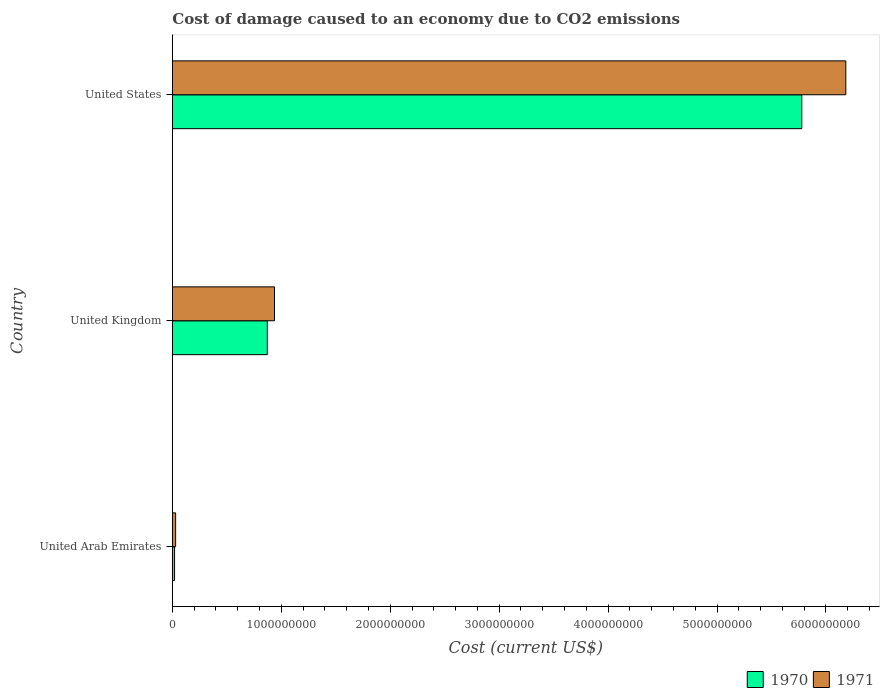How many different coloured bars are there?
Make the answer very short. 2. Are the number of bars per tick equal to the number of legend labels?
Provide a succinct answer. Yes. How many bars are there on the 2nd tick from the bottom?
Your answer should be very brief. 2. What is the label of the 3rd group of bars from the top?
Give a very brief answer. United Arab Emirates. What is the cost of damage caused due to CO2 emissisons in 1971 in United Arab Emirates?
Your answer should be very brief. 3.01e+07. Across all countries, what is the maximum cost of damage caused due to CO2 emissisons in 1971?
Ensure brevity in your answer.  6.18e+09. Across all countries, what is the minimum cost of damage caused due to CO2 emissisons in 1971?
Give a very brief answer. 3.01e+07. In which country was the cost of damage caused due to CO2 emissisons in 1971 minimum?
Your response must be concise. United Arab Emirates. What is the total cost of damage caused due to CO2 emissisons in 1971 in the graph?
Your response must be concise. 7.15e+09. What is the difference between the cost of damage caused due to CO2 emissisons in 1970 in United Arab Emirates and that in United States?
Make the answer very short. -5.76e+09. What is the difference between the cost of damage caused due to CO2 emissisons in 1971 in United Arab Emirates and the cost of damage caused due to CO2 emissisons in 1970 in United Kingdom?
Give a very brief answer. -8.42e+08. What is the average cost of damage caused due to CO2 emissisons in 1970 per country?
Make the answer very short. 2.22e+09. What is the difference between the cost of damage caused due to CO2 emissisons in 1970 and cost of damage caused due to CO2 emissisons in 1971 in United Kingdom?
Provide a short and direct response. -6.61e+07. What is the ratio of the cost of damage caused due to CO2 emissisons in 1971 in United Kingdom to that in United States?
Ensure brevity in your answer.  0.15. Is the cost of damage caused due to CO2 emissisons in 1970 in United Arab Emirates less than that in United Kingdom?
Keep it short and to the point. Yes. Is the difference between the cost of damage caused due to CO2 emissisons in 1970 in United Arab Emirates and United Kingdom greater than the difference between the cost of damage caused due to CO2 emissisons in 1971 in United Arab Emirates and United Kingdom?
Give a very brief answer. Yes. What is the difference between the highest and the second highest cost of damage caused due to CO2 emissisons in 1970?
Keep it short and to the point. 4.91e+09. What is the difference between the highest and the lowest cost of damage caused due to CO2 emissisons in 1971?
Keep it short and to the point. 6.15e+09. What does the 2nd bar from the top in United Arab Emirates represents?
Give a very brief answer. 1970. What does the 1st bar from the bottom in United States represents?
Offer a very short reply. 1970. How many bars are there?
Make the answer very short. 6. How many countries are there in the graph?
Your answer should be very brief. 3. What is the difference between two consecutive major ticks on the X-axis?
Give a very brief answer. 1.00e+09. Are the values on the major ticks of X-axis written in scientific E-notation?
Provide a succinct answer. No. Does the graph contain any zero values?
Your answer should be compact. No. Where does the legend appear in the graph?
Provide a succinct answer. Bottom right. What is the title of the graph?
Ensure brevity in your answer.  Cost of damage caused to an economy due to CO2 emissions. What is the label or title of the X-axis?
Keep it short and to the point. Cost (current US$). What is the Cost (current US$) of 1970 in United Arab Emirates?
Ensure brevity in your answer.  2.04e+07. What is the Cost (current US$) in 1971 in United Arab Emirates?
Your answer should be compact. 3.01e+07. What is the Cost (current US$) of 1970 in United Kingdom?
Offer a terse response. 8.72e+08. What is the Cost (current US$) in 1971 in United Kingdom?
Offer a very short reply. 9.38e+08. What is the Cost (current US$) of 1970 in United States?
Your answer should be compact. 5.78e+09. What is the Cost (current US$) of 1971 in United States?
Offer a very short reply. 6.18e+09. Across all countries, what is the maximum Cost (current US$) of 1970?
Offer a terse response. 5.78e+09. Across all countries, what is the maximum Cost (current US$) of 1971?
Your answer should be very brief. 6.18e+09. Across all countries, what is the minimum Cost (current US$) of 1970?
Keep it short and to the point. 2.04e+07. Across all countries, what is the minimum Cost (current US$) in 1971?
Keep it short and to the point. 3.01e+07. What is the total Cost (current US$) of 1970 in the graph?
Offer a very short reply. 6.67e+09. What is the total Cost (current US$) of 1971 in the graph?
Give a very brief answer. 7.15e+09. What is the difference between the Cost (current US$) in 1970 in United Arab Emirates and that in United Kingdom?
Provide a succinct answer. -8.51e+08. What is the difference between the Cost (current US$) in 1971 in United Arab Emirates and that in United Kingdom?
Your answer should be very brief. -9.08e+08. What is the difference between the Cost (current US$) in 1970 in United Arab Emirates and that in United States?
Keep it short and to the point. -5.76e+09. What is the difference between the Cost (current US$) in 1971 in United Arab Emirates and that in United States?
Your answer should be very brief. -6.15e+09. What is the difference between the Cost (current US$) in 1970 in United Kingdom and that in United States?
Offer a terse response. -4.91e+09. What is the difference between the Cost (current US$) in 1971 in United Kingdom and that in United States?
Ensure brevity in your answer.  -5.24e+09. What is the difference between the Cost (current US$) in 1970 in United Arab Emirates and the Cost (current US$) in 1971 in United Kingdom?
Give a very brief answer. -9.17e+08. What is the difference between the Cost (current US$) of 1970 in United Arab Emirates and the Cost (current US$) of 1971 in United States?
Ensure brevity in your answer.  -6.16e+09. What is the difference between the Cost (current US$) of 1970 in United Kingdom and the Cost (current US$) of 1971 in United States?
Your answer should be very brief. -5.31e+09. What is the average Cost (current US$) of 1970 per country?
Keep it short and to the point. 2.22e+09. What is the average Cost (current US$) of 1971 per country?
Ensure brevity in your answer.  2.38e+09. What is the difference between the Cost (current US$) in 1970 and Cost (current US$) in 1971 in United Arab Emirates?
Keep it short and to the point. -9.71e+06. What is the difference between the Cost (current US$) in 1970 and Cost (current US$) in 1971 in United Kingdom?
Make the answer very short. -6.61e+07. What is the difference between the Cost (current US$) of 1970 and Cost (current US$) of 1971 in United States?
Provide a succinct answer. -4.04e+08. What is the ratio of the Cost (current US$) in 1970 in United Arab Emirates to that in United Kingdom?
Offer a terse response. 0.02. What is the ratio of the Cost (current US$) of 1971 in United Arab Emirates to that in United Kingdom?
Offer a terse response. 0.03. What is the ratio of the Cost (current US$) of 1970 in United Arab Emirates to that in United States?
Ensure brevity in your answer.  0. What is the ratio of the Cost (current US$) of 1971 in United Arab Emirates to that in United States?
Your answer should be very brief. 0. What is the ratio of the Cost (current US$) in 1970 in United Kingdom to that in United States?
Offer a very short reply. 0.15. What is the ratio of the Cost (current US$) of 1971 in United Kingdom to that in United States?
Offer a very short reply. 0.15. What is the difference between the highest and the second highest Cost (current US$) in 1970?
Give a very brief answer. 4.91e+09. What is the difference between the highest and the second highest Cost (current US$) of 1971?
Provide a short and direct response. 5.24e+09. What is the difference between the highest and the lowest Cost (current US$) in 1970?
Offer a terse response. 5.76e+09. What is the difference between the highest and the lowest Cost (current US$) of 1971?
Your answer should be very brief. 6.15e+09. 